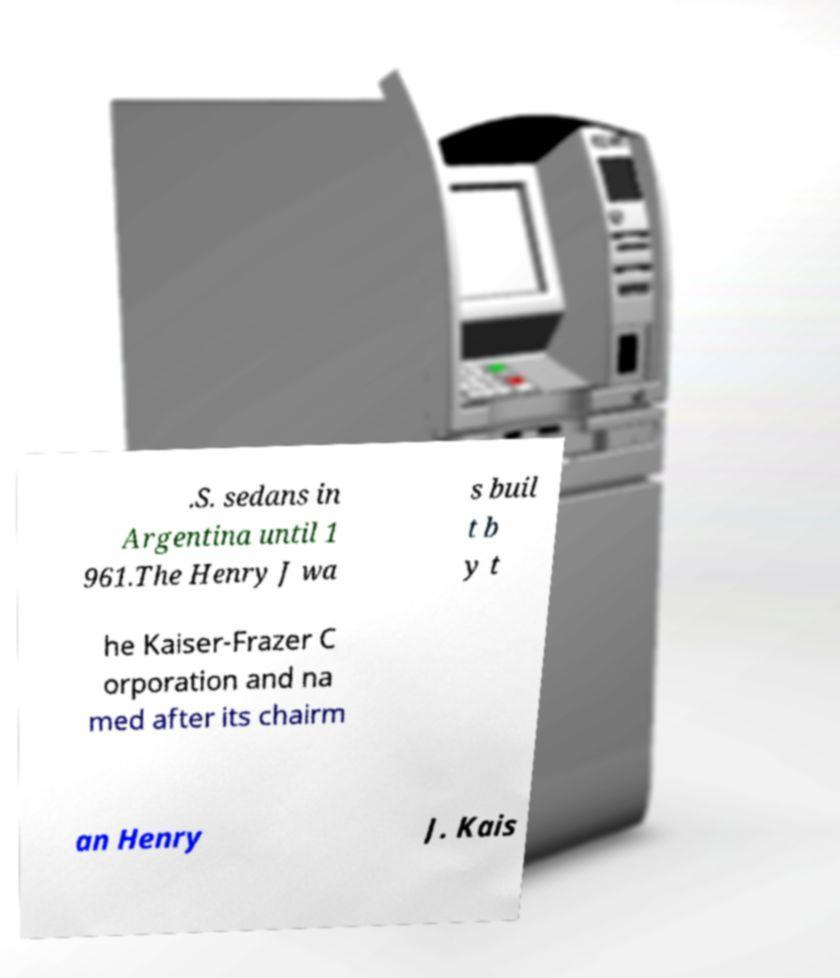Could you extract and type out the text from this image? .S. sedans in Argentina until 1 961.The Henry J wa s buil t b y t he Kaiser-Frazer C orporation and na med after its chairm an Henry J. Kais 